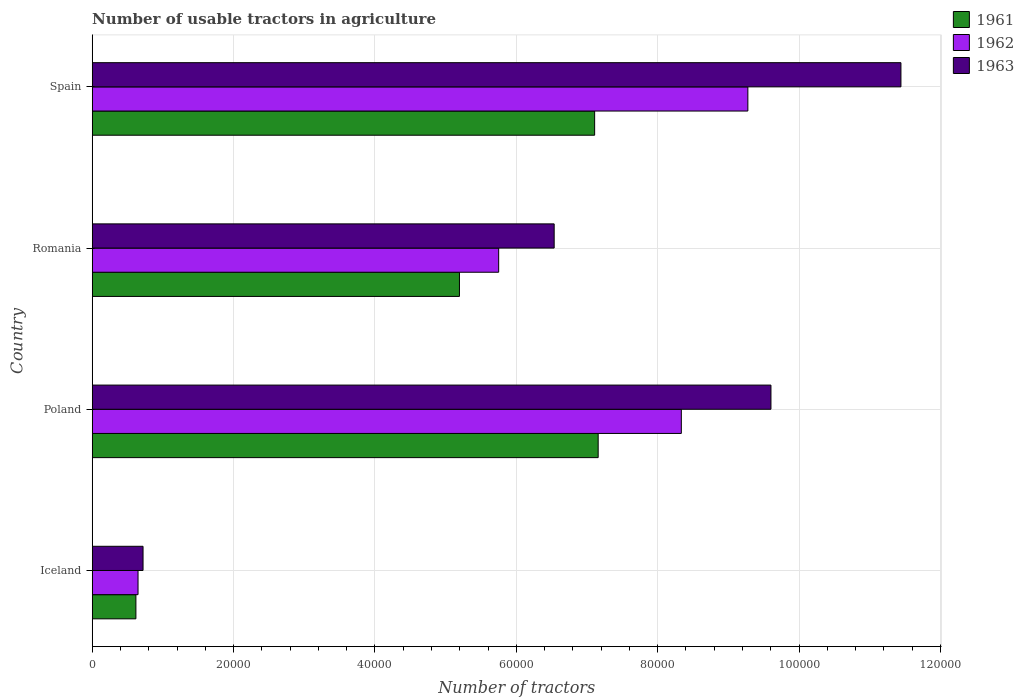How many different coloured bars are there?
Keep it short and to the point. 3. How many groups of bars are there?
Give a very brief answer. 4. Are the number of bars on each tick of the Y-axis equal?
Provide a succinct answer. Yes. How many bars are there on the 3rd tick from the bottom?
Your answer should be very brief. 3. What is the label of the 3rd group of bars from the top?
Make the answer very short. Poland. What is the number of usable tractors in agriculture in 1962 in Iceland?
Offer a terse response. 6479. Across all countries, what is the maximum number of usable tractors in agriculture in 1963?
Give a very brief answer. 1.14e+05. Across all countries, what is the minimum number of usable tractors in agriculture in 1963?
Offer a terse response. 7187. What is the total number of usable tractors in agriculture in 1962 in the graph?
Your response must be concise. 2.40e+05. What is the difference between the number of usable tractors in agriculture in 1963 in Iceland and that in Spain?
Your answer should be compact. -1.07e+05. What is the difference between the number of usable tractors in agriculture in 1962 in Spain and the number of usable tractors in agriculture in 1961 in Iceland?
Offer a very short reply. 8.66e+04. What is the average number of usable tractors in agriculture in 1963 per country?
Provide a succinct answer. 7.07e+04. What is the difference between the number of usable tractors in agriculture in 1961 and number of usable tractors in agriculture in 1962 in Romania?
Offer a terse response. -5548. What is the ratio of the number of usable tractors in agriculture in 1962 in Poland to that in Romania?
Offer a very short reply. 1.45. Is the number of usable tractors in agriculture in 1961 in Iceland less than that in Spain?
Your answer should be very brief. Yes. Is the difference between the number of usable tractors in agriculture in 1961 in Iceland and Spain greater than the difference between the number of usable tractors in agriculture in 1962 in Iceland and Spain?
Your response must be concise. Yes. What is the difference between the highest and the second highest number of usable tractors in agriculture in 1962?
Provide a short and direct response. 9414. What is the difference between the highest and the lowest number of usable tractors in agriculture in 1961?
Your answer should be very brief. 6.54e+04. What does the 2nd bar from the top in Romania represents?
Your answer should be very brief. 1962. Are all the bars in the graph horizontal?
Provide a succinct answer. Yes. Does the graph contain any zero values?
Offer a very short reply. No. Does the graph contain grids?
Your answer should be compact. Yes. How many legend labels are there?
Give a very brief answer. 3. What is the title of the graph?
Provide a succinct answer. Number of usable tractors in agriculture. Does "2006" appear as one of the legend labels in the graph?
Provide a succinct answer. No. What is the label or title of the X-axis?
Make the answer very short. Number of tractors. What is the Number of tractors in 1961 in Iceland?
Keep it short and to the point. 6177. What is the Number of tractors of 1962 in Iceland?
Give a very brief answer. 6479. What is the Number of tractors of 1963 in Iceland?
Your answer should be very brief. 7187. What is the Number of tractors in 1961 in Poland?
Your answer should be compact. 7.16e+04. What is the Number of tractors in 1962 in Poland?
Your answer should be compact. 8.33e+04. What is the Number of tractors in 1963 in Poland?
Keep it short and to the point. 9.60e+04. What is the Number of tractors in 1961 in Romania?
Provide a succinct answer. 5.20e+04. What is the Number of tractors in 1962 in Romania?
Offer a very short reply. 5.75e+04. What is the Number of tractors in 1963 in Romania?
Your answer should be very brief. 6.54e+04. What is the Number of tractors of 1961 in Spain?
Provide a succinct answer. 7.11e+04. What is the Number of tractors in 1962 in Spain?
Make the answer very short. 9.28e+04. What is the Number of tractors of 1963 in Spain?
Keep it short and to the point. 1.14e+05. Across all countries, what is the maximum Number of tractors of 1961?
Keep it short and to the point. 7.16e+04. Across all countries, what is the maximum Number of tractors of 1962?
Give a very brief answer. 9.28e+04. Across all countries, what is the maximum Number of tractors in 1963?
Offer a very short reply. 1.14e+05. Across all countries, what is the minimum Number of tractors of 1961?
Your answer should be very brief. 6177. Across all countries, what is the minimum Number of tractors of 1962?
Your answer should be compact. 6479. Across all countries, what is the minimum Number of tractors of 1963?
Give a very brief answer. 7187. What is the total Number of tractors in 1961 in the graph?
Your answer should be very brief. 2.01e+05. What is the total Number of tractors of 1962 in the graph?
Offer a very short reply. 2.40e+05. What is the total Number of tractors in 1963 in the graph?
Ensure brevity in your answer.  2.83e+05. What is the difference between the Number of tractors of 1961 in Iceland and that in Poland?
Your answer should be compact. -6.54e+04. What is the difference between the Number of tractors in 1962 in Iceland and that in Poland?
Offer a terse response. -7.69e+04. What is the difference between the Number of tractors of 1963 in Iceland and that in Poland?
Your answer should be very brief. -8.88e+04. What is the difference between the Number of tractors in 1961 in Iceland and that in Romania?
Offer a terse response. -4.58e+04. What is the difference between the Number of tractors of 1962 in Iceland and that in Romania?
Ensure brevity in your answer.  -5.10e+04. What is the difference between the Number of tractors in 1963 in Iceland and that in Romania?
Give a very brief answer. -5.82e+04. What is the difference between the Number of tractors in 1961 in Iceland and that in Spain?
Keep it short and to the point. -6.49e+04. What is the difference between the Number of tractors of 1962 in Iceland and that in Spain?
Your response must be concise. -8.63e+04. What is the difference between the Number of tractors in 1963 in Iceland and that in Spain?
Provide a short and direct response. -1.07e+05. What is the difference between the Number of tractors in 1961 in Poland and that in Romania?
Offer a very short reply. 1.96e+04. What is the difference between the Number of tractors of 1962 in Poland and that in Romania?
Offer a very short reply. 2.58e+04. What is the difference between the Number of tractors in 1963 in Poland and that in Romania?
Make the answer very short. 3.07e+04. What is the difference between the Number of tractors of 1962 in Poland and that in Spain?
Provide a short and direct response. -9414. What is the difference between the Number of tractors of 1963 in Poland and that in Spain?
Your answer should be compact. -1.84e+04. What is the difference between the Number of tractors in 1961 in Romania and that in Spain?
Your response must be concise. -1.91e+04. What is the difference between the Number of tractors of 1962 in Romania and that in Spain?
Give a very brief answer. -3.53e+04. What is the difference between the Number of tractors of 1963 in Romania and that in Spain?
Your response must be concise. -4.91e+04. What is the difference between the Number of tractors in 1961 in Iceland and the Number of tractors in 1962 in Poland?
Your answer should be compact. -7.72e+04. What is the difference between the Number of tractors in 1961 in Iceland and the Number of tractors in 1963 in Poland?
Make the answer very short. -8.98e+04. What is the difference between the Number of tractors of 1962 in Iceland and the Number of tractors of 1963 in Poland?
Give a very brief answer. -8.95e+04. What is the difference between the Number of tractors of 1961 in Iceland and the Number of tractors of 1962 in Romania?
Provide a succinct answer. -5.13e+04. What is the difference between the Number of tractors of 1961 in Iceland and the Number of tractors of 1963 in Romania?
Your answer should be very brief. -5.92e+04. What is the difference between the Number of tractors in 1962 in Iceland and the Number of tractors in 1963 in Romania?
Give a very brief answer. -5.89e+04. What is the difference between the Number of tractors in 1961 in Iceland and the Number of tractors in 1962 in Spain?
Make the answer very short. -8.66e+04. What is the difference between the Number of tractors in 1961 in Iceland and the Number of tractors in 1963 in Spain?
Make the answer very short. -1.08e+05. What is the difference between the Number of tractors of 1962 in Iceland and the Number of tractors of 1963 in Spain?
Your answer should be very brief. -1.08e+05. What is the difference between the Number of tractors of 1961 in Poland and the Number of tractors of 1962 in Romania?
Your response must be concise. 1.41e+04. What is the difference between the Number of tractors in 1961 in Poland and the Number of tractors in 1963 in Romania?
Provide a succinct answer. 6226. What is the difference between the Number of tractors in 1962 in Poland and the Number of tractors in 1963 in Romania?
Your answer should be compact. 1.80e+04. What is the difference between the Number of tractors of 1961 in Poland and the Number of tractors of 1962 in Spain?
Offer a very short reply. -2.12e+04. What is the difference between the Number of tractors in 1961 in Poland and the Number of tractors in 1963 in Spain?
Your answer should be very brief. -4.28e+04. What is the difference between the Number of tractors in 1962 in Poland and the Number of tractors in 1963 in Spain?
Provide a short and direct response. -3.11e+04. What is the difference between the Number of tractors of 1961 in Romania and the Number of tractors of 1962 in Spain?
Your answer should be very brief. -4.08e+04. What is the difference between the Number of tractors in 1961 in Romania and the Number of tractors in 1963 in Spain?
Provide a succinct answer. -6.25e+04. What is the difference between the Number of tractors in 1962 in Romania and the Number of tractors in 1963 in Spain?
Offer a very short reply. -5.69e+04. What is the average Number of tractors of 1961 per country?
Offer a terse response. 5.02e+04. What is the average Number of tractors in 1962 per country?
Offer a very short reply. 6.00e+04. What is the average Number of tractors in 1963 per country?
Make the answer very short. 7.07e+04. What is the difference between the Number of tractors of 1961 and Number of tractors of 1962 in Iceland?
Ensure brevity in your answer.  -302. What is the difference between the Number of tractors in 1961 and Number of tractors in 1963 in Iceland?
Make the answer very short. -1010. What is the difference between the Number of tractors of 1962 and Number of tractors of 1963 in Iceland?
Offer a terse response. -708. What is the difference between the Number of tractors in 1961 and Number of tractors in 1962 in Poland?
Provide a succinct answer. -1.18e+04. What is the difference between the Number of tractors of 1961 and Number of tractors of 1963 in Poland?
Ensure brevity in your answer.  -2.44e+04. What is the difference between the Number of tractors in 1962 and Number of tractors in 1963 in Poland?
Ensure brevity in your answer.  -1.27e+04. What is the difference between the Number of tractors of 1961 and Number of tractors of 1962 in Romania?
Offer a very short reply. -5548. What is the difference between the Number of tractors in 1961 and Number of tractors in 1963 in Romania?
Offer a very short reply. -1.34e+04. What is the difference between the Number of tractors in 1962 and Number of tractors in 1963 in Romania?
Your answer should be compact. -7851. What is the difference between the Number of tractors of 1961 and Number of tractors of 1962 in Spain?
Provide a short and direct response. -2.17e+04. What is the difference between the Number of tractors of 1961 and Number of tractors of 1963 in Spain?
Keep it short and to the point. -4.33e+04. What is the difference between the Number of tractors in 1962 and Number of tractors in 1963 in Spain?
Provide a short and direct response. -2.17e+04. What is the ratio of the Number of tractors in 1961 in Iceland to that in Poland?
Keep it short and to the point. 0.09. What is the ratio of the Number of tractors in 1962 in Iceland to that in Poland?
Offer a very short reply. 0.08. What is the ratio of the Number of tractors of 1963 in Iceland to that in Poland?
Offer a very short reply. 0.07. What is the ratio of the Number of tractors of 1961 in Iceland to that in Romania?
Ensure brevity in your answer.  0.12. What is the ratio of the Number of tractors in 1962 in Iceland to that in Romania?
Provide a succinct answer. 0.11. What is the ratio of the Number of tractors of 1963 in Iceland to that in Romania?
Offer a very short reply. 0.11. What is the ratio of the Number of tractors of 1961 in Iceland to that in Spain?
Your answer should be very brief. 0.09. What is the ratio of the Number of tractors of 1962 in Iceland to that in Spain?
Offer a very short reply. 0.07. What is the ratio of the Number of tractors in 1963 in Iceland to that in Spain?
Make the answer very short. 0.06. What is the ratio of the Number of tractors of 1961 in Poland to that in Romania?
Your answer should be compact. 1.38. What is the ratio of the Number of tractors in 1962 in Poland to that in Romania?
Provide a succinct answer. 1.45. What is the ratio of the Number of tractors of 1963 in Poland to that in Romania?
Offer a very short reply. 1.47. What is the ratio of the Number of tractors in 1962 in Poland to that in Spain?
Provide a succinct answer. 0.9. What is the ratio of the Number of tractors in 1963 in Poland to that in Spain?
Provide a short and direct response. 0.84. What is the ratio of the Number of tractors in 1961 in Romania to that in Spain?
Provide a succinct answer. 0.73. What is the ratio of the Number of tractors of 1962 in Romania to that in Spain?
Offer a terse response. 0.62. What is the ratio of the Number of tractors of 1963 in Romania to that in Spain?
Make the answer very short. 0.57. What is the difference between the highest and the second highest Number of tractors in 1962?
Provide a short and direct response. 9414. What is the difference between the highest and the second highest Number of tractors in 1963?
Make the answer very short. 1.84e+04. What is the difference between the highest and the lowest Number of tractors of 1961?
Your response must be concise. 6.54e+04. What is the difference between the highest and the lowest Number of tractors in 1962?
Give a very brief answer. 8.63e+04. What is the difference between the highest and the lowest Number of tractors of 1963?
Ensure brevity in your answer.  1.07e+05. 